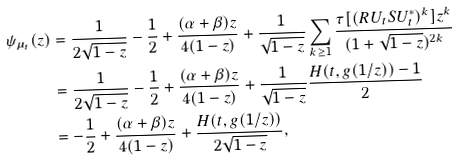Convert formula to latex. <formula><loc_0><loc_0><loc_500><loc_500>\psi _ { \mu _ { t } } ( z ) & = \frac { 1 } { 2 \sqrt { 1 - z } } - \frac { 1 } { 2 } + \frac { ( \alpha + \beta ) z } { 4 ( 1 - z ) } + \frac { 1 } { \sqrt { 1 - z } } \sum _ { k \geq 1 } \frac { \tau [ ( R U _ { t } S U _ { t } ^ { * } ) ^ { k } ] z ^ { k } } { ( 1 + \sqrt { 1 - z } ) ^ { 2 k } } \\ & = \frac { 1 } { 2 \sqrt { 1 - z } } - \frac { 1 } { 2 } + \frac { ( \alpha + \beta ) z } { 4 ( 1 - z ) } + \frac { 1 } { \sqrt { 1 - z } } \frac { H ( t , g ( 1 / z ) ) - 1 } { 2 } \\ & = - \frac { 1 } { 2 } + \frac { ( \alpha + \beta ) z } { 4 ( 1 - z ) } + \frac { H ( t , g ( 1 / z ) ) } { 2 \sqrt { 1 - z } } ,</formula> 